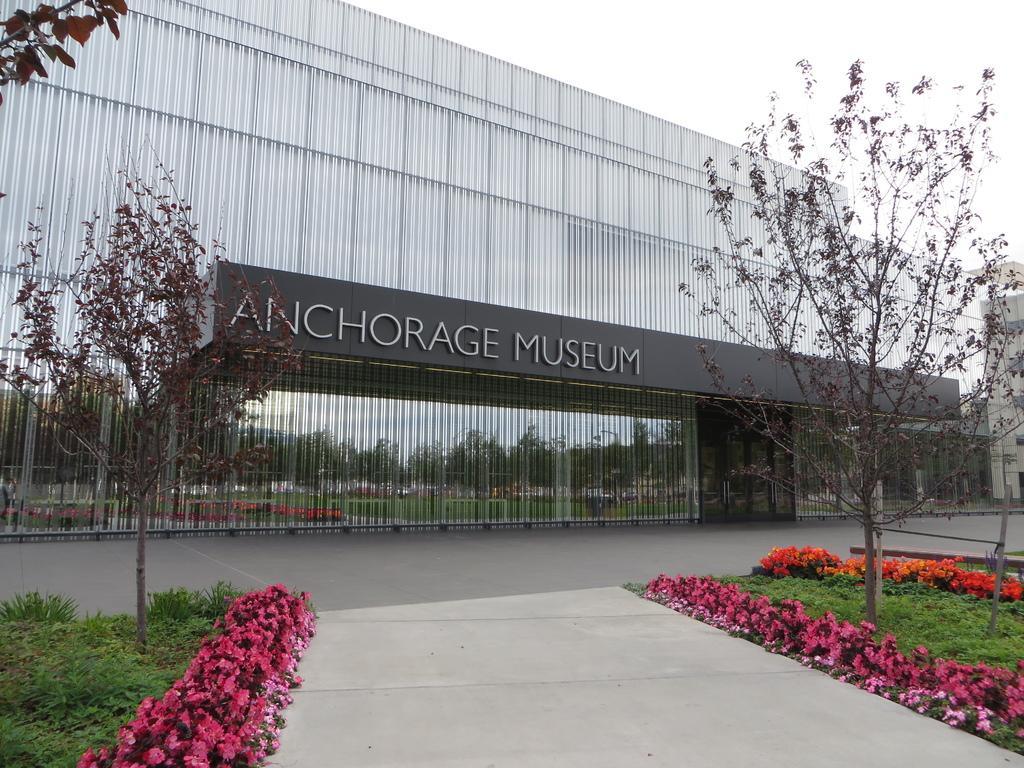Could you give a brief overview of what you see in this image? In the picture we can see a museum building and written on it as Anchorage museum and near to it, we can see a path and the pathway and besides the pathway we can see which flowers are pink in color and a grass surface and on it we can see some trees and in the background we can see a sky. 